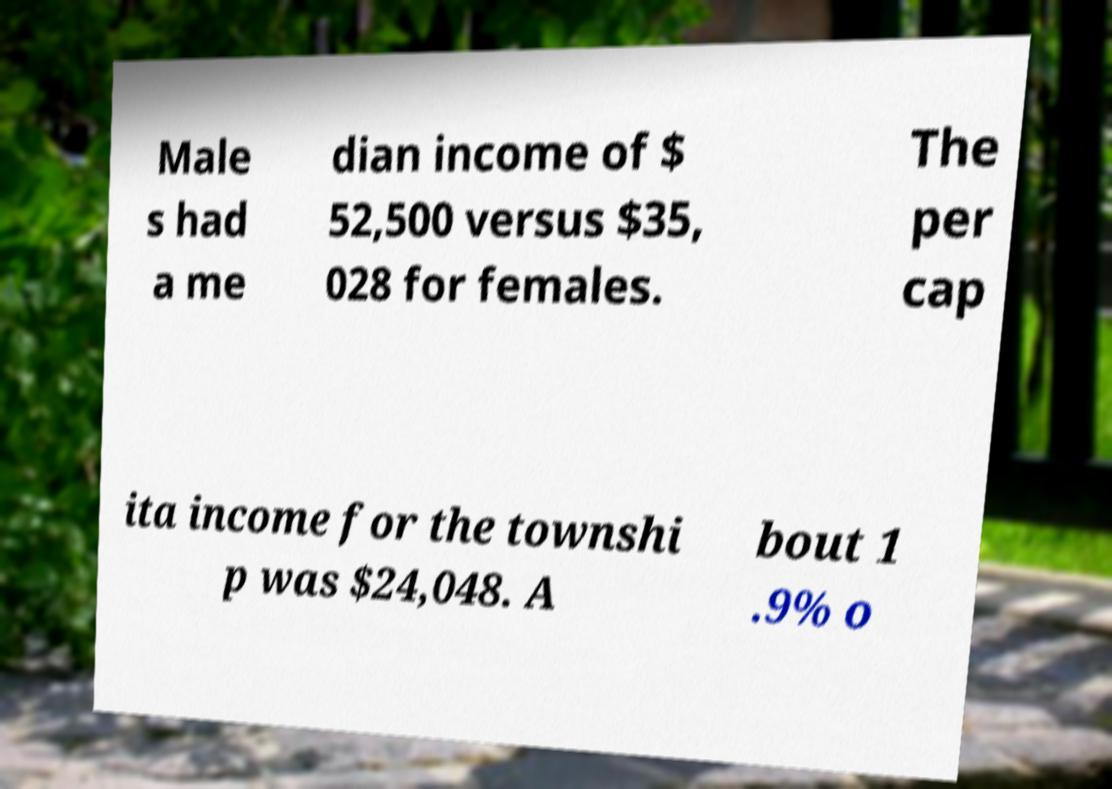Please read and relay the text visible in this image. What does it say? Male s had a me dian income of $ 52,500 versus $35, 028 for females. The per cap ita income for the townshi p was $24,048. A bout 1 .9% o 